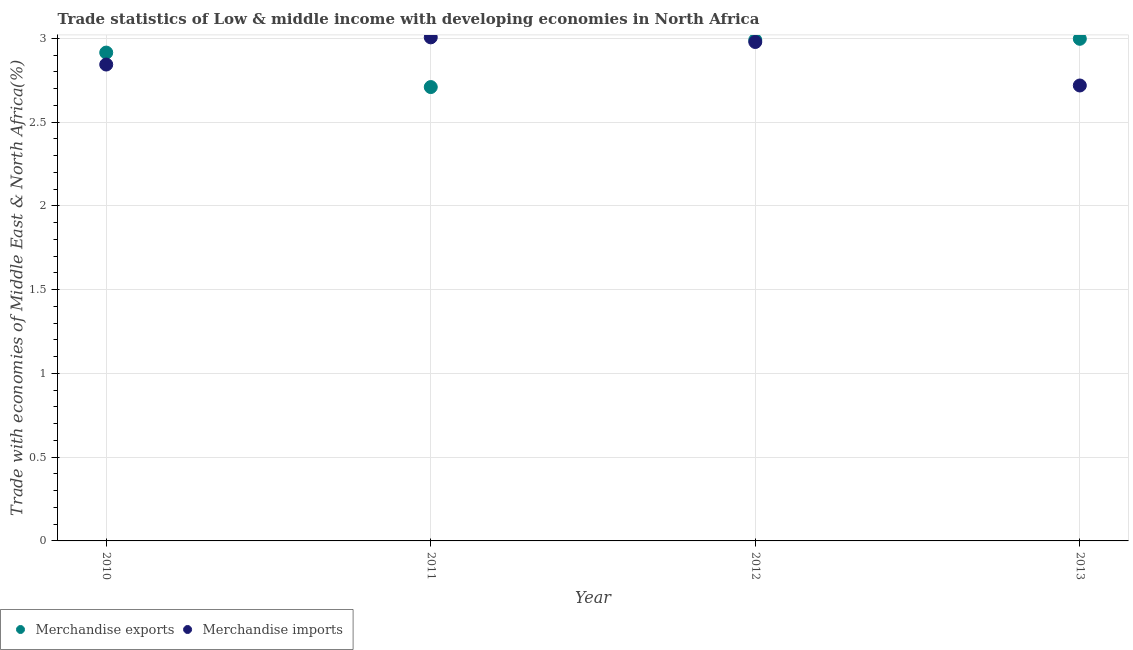Is the number of dotlines equal to the number of legend labels?
Provide a succinct answer. Yes. What is the merchandise exports in 2010?
Give a very brief answer. 2.91. Across all years, what is the maximum merchandise exports?
Offer a very short reply. 3. Across all years, what is the minimum merchandise exports?
Your answer should be compact. 2.71. What is the total merchandise imports in the graph?
Offer a very short reply. 11.54. What is the difference between the merchandise imports in 2010 and that in 2012?
Your response must be concise. -0.13. What is the difference between the merchandise exports in 2011 and the merchandise imports in 2013?
Keep it short and to the point. -0.01. What is the average merchandise exports per year?
Your answer should be very brief. 2.9. In the year 2011, what is the difference between the merchandise exports and merchandise imports?
Your response must be concise. -0.3. In how many years, is the merchandise exports greater than 2 %?
Make the answer very short. 4. What is the ratio of the merchandise exports in 2012 to that in 2013?
Make the answer very short. 1. Is the merchandise imports in 2010 less than that in 2011?
Keep it short and to the point. Yes. Is the difference between the merchandise exports in 2011 and 2013 greater than the difference between the merchandise imports in 2011 and 2013?
Your answer should be compact. No. What is the difference between the highest and the second highest merchandise imports?
Give a very brief answer. 0.03. What is the difference between the highest and the lowest merchandise exports?
Offer a terse response. 0.29. In how many years, is the merchandise exports greater than the average merchandise exports taken over all years?
Ensure brevity in your answer.  3. Is the sum of the merchandise imports in 2011 and 2013 greater than the maximum merchandise exports across all years?
Your response must be concise. Yes. How many dotlines are there?
Your answer should be compact. 2. What is the difference between two consecutive major ticks on the Y-axis?
Provide a succinct answer. 0.5. Does the graph contain any zero values?
Offer a terse response. No. What is the title of the graph?
Your response must be concise. Trade statistics of Low & middle income with developing economies in North Africa. What is the label or title of the X-axis?
Offer a very short reply. Year. What is the label or title of the Y-axis?
Ensure brevity in your answer.  Trade with economies of Middle East & North Africa(%). What is the Trade with economies of Middle East & North Africa(%) in Merchandise exports in 2010?
Your answer should be compact. 2.91. What is the Trade with economies of Middle East & North Africa(%) of Merchandise imports in 2010?
Make the answer very short. 2.84. What is the Trade with economies of Middle East & North Africa(%) in Merchandise exports in 2011?
Provide a succinct answer. 2.71. What is the Trade with economies of Middle East & North Africa(%) of Merchandise imports in 2011?
Your response must be concise. 3.01. What is the Trade with economies of Middle East & North Africa(%) of Merchandise exports in 2012?
Your answer should be very brief. 2.99. What is the Trade with economies of Middle East & North Africa(%) in Merchandise imports in 2012?
Make the answer very short. 2.98. What is the Trade with economies of Middle East & North Africa(%) in Merchandise exports in 2013?
Keep it short and to the point. 3. What is the Trade with economies of Middle East & North Africa(%) in Merchandise imports in 2013?
Keep it short and to the point. 2.72. Across all years, what is the maximum Trade with economies of Middle East & North Africa(%) in Merchandise exports?
Give a very brief answer. 3. Across all years, what is the maximum Trade with economies of Middle East & North Africa(%) in Merchandise imports?
Give a very brief answer. 3.01. Across all years, what is the minimum Trade with economies of Middle East & North Africa(%) of Merchandise exports?
Give a very brief answer. 2.71. Across all years, what is the minimum Trade with economies of Middle East & North Africa(%) of Merchandise imports?
Give a very brief answer. 2.72. What is the total Trade with economies of Middle East & North Africa(%) of Merchandise exports in the graph?
Your answer should be compact. 11.61. What is the total Trade with economies of Middle East & North Africa(%) in Merchandise imports in the graph?
Offer a terse response. 11.54. What is the difference between the Trade with economies of Middle East & North Africa(%) in Merchandise exports in 2010 and that in 2011?
Provide a short and direct response. 0.21. What is the difference between the Trade with economies of Middle East & North Africa(%) in Merchandise imports in 2010 and that in 2011?
Your answer should be very brief. -0.16. What is the difference between the Trade with economies of Middle East & North Africa(%) of Merchandise exports in 2010 and that in 2012?
Offer a terse response. -0.07. What is the difference between the Trade with economies of Middle East & North Africa(%) of Merchandise imports in 2010 and that in 2012?
Keep it short and to the point. -0.13. What is the difference between the Trade with economies of Middle East & North Africa(%) of Merchandise exports in 2010 and that in 2013?
Give a very brief answer. -0.08. What is the difference between the Trade with economies of Middle East & North Africa(%) in Merchandise imports in 2010 and that in 2013?
Ensure brevity in your answer.  0.12. What is the difference between the Trade with economies of Middle East & North Africa(%) in Merchandise exports in 2011 and that in 2012?
Provide a short and direct response. -0.28. What is the difference between the Trade with economies of Middle East & North Africa(%) of Merchandise imports in 2011 and that in 2012?
Keep it short and to the point. 0.03. What is the difference between the Trade with economies of Middle East & North Africa(%) in Merchandise exports in 2011 and that in 2013?
Your answer should be compact. -0.29. What is the difference between the Trade with economies of Middle East & North Africa(%) in Merchandise imports in 2011 and that in 2013?
Give a very brief answer. 0.29. What is the difference between the Trade with economies of Middle East & North Africa(%) of Merchandise exports in 2012 and that in 2013?
Make the answer very short. -0.01. What is the difference between the Trade with economies of Middle East & North Africa(%) in Merchandise imports in 2012 and that in 2013?
Your answer should be compact. 0.26. What is the difference between the Trade with economies of Middle East & North Africa(%) of Merchandise exports in 2010 and the Trade with economies of Middle East & North Africa(%) of Merchandise imports in 2011?
Your answer should be very brief. -0.09. What is the difference between the Trade with economies of Middle East & North Africa(%) in Merchandise exports in 2010 and the Trade with economies of Middle East & North Africa(%) in Merchandise imports in 2012?
Offer a terse response. -0.06. What is the difference between the Trade with economies of Middle East & North Africa(%) of Merchandise exports in 2010 and the Trade with economies of Middle East & North Africa(%) of Merchandise imports in 2013?
Keep it short and to the point. 0.2. What is the difference between the Trade with economies of Middle East & North Africa(%) in Merchandise exports in 2011 and the Trade with economies of Middle East & North Africa(%) in Merchandise imports in 2012?
Your answer should be compact. -0.27. What is the difference between the Trade with economies of Middle East & North Africa(%) of Merchandise exports in 2011 and the Trade with economies of Middle East & North Africa(%) of Merchandise imports in 2013?
Make the answer very short. -0.01. What is the difference between the Trade with economies of Middle East & North Africa(%) in Merchandise exports in 2012 and the Trade with economies of Middle East & North Africa(%) in Merchandise imports in 2013?
Offer a terse response. 0.27. What is the average Trade with economies of Middle East & North Africa(%) of Merchandise exports per year?
Your answer should be very brief. 2.9. What is the average Trade with economies of Middle East & North Africa(%) of Merchandise imports per year?
Make the answer very short. 2.89. In the year 2010, what is the difference between the Trade with economies of Middle East & North Africa(%) of Merchandise exports and Trade with economies of Middle East & North Africa(%) of Merchandise imports?
Offer a terse response. 0.07. In the year 2011, what is the difference between the Trade with economies of Middle East & North Africa(%) in Merchandise exports and Trade with economies of Middle East & North Africa(%) in Merchandise imports?
Give a very brief answer. -0.3. In the year 2012, what is the difference between the Trade with economies of Middle East & North Africa(%) of Merchandise exports and Trade with economies of Middle East & North Africa(%) of Merchandise imports?
Ensure brevity in your answer.  0.01. In the year 2013, what is the difference between the Trade with economies of Middle East & North Africa(%) in Merchandise exports and Trade with economies of Middle East & North Africa(%) in Merchandise imports?
Ensure brevity in your answer.  0.28. What is the ratio of the Trade with economies of Middle East & North Africa(%) of Merchandise exports in 2010 to that in 2011?
Make the answer very short. 1.08. What is the ratio of the Trade with economies of Middle East & North Africa(%) of Merchandise imports in 2010 to that in 2011?
Provide a succinct answer. 0.95. What is the ratio of the Trade with economies of Middle East & North Africa(%) of Merchandise exports in 2010 to that in 2012?
Ensure brevity in your answer.  0.97. What is the ratio of the Trade with economies of Middle East & North Africa(%) of Merchandise imports in 2010 to that in 2012?
Offer a terse response. 0.95. What is the ratio of the Trade with economies of Middle East & North Africa(%) of Merchandise exports in 2010 to that in 2013?
Ensure brevity in your answer.  0.97. What is the ratio of the Trade with economies of Middle East & North Africa(%) in Merchandise imports in 2010 to that in 2013?
Offer a terse response. 1.05. What is the ratio of the Trade with economies of Middle East & North Africa(%) in Merchandise exports in 2011 to that in 2012?
Your answer should be compact. 0.91. What is the ratio of the Trade with economies of Middle East & North Africa(%) of Merchandise imports in 2011 to that in 2012?
Keep it short and to the point. 1.01. What is the ratio of the Trade with economies of Middle East & North Africa(%) of Merchandise exports in 2011 to that in 2013?
Provide a short and direct response. 0.9. What is the ratio of the Trade with economies of Middle East & North Africa(%) of Merchandise imports in 2011 to that in 2013?
Your answer should be very brief. 1.11. What is the ratio of the Trade with economies of Middle East & North Africa(%) in Merchandise imports in 2012 to that in 2013?
Make the answer very short. 1.1. What is the difference between the highest and the second highest Trade with economies of Middle East & North Africa(%) of Merchandise exports?
Provide a succinct answer. 0.01. What is the difference between the highest and the second highest Trade with economies of Middle East & North Africa(%) of Merchandise imports?
Provide a succinct answer. 0.03. What is the difference between the highest and the lowest Trade with economies of Middle East & North Africa(%) of Merchandise exports?
Your answer should be very brief. 0.29. What is the difference between the highest and the lowest Trade with economies of Middle East & North Africa(%) of Merchandise imports?
Your response must be concise. 0.29. 